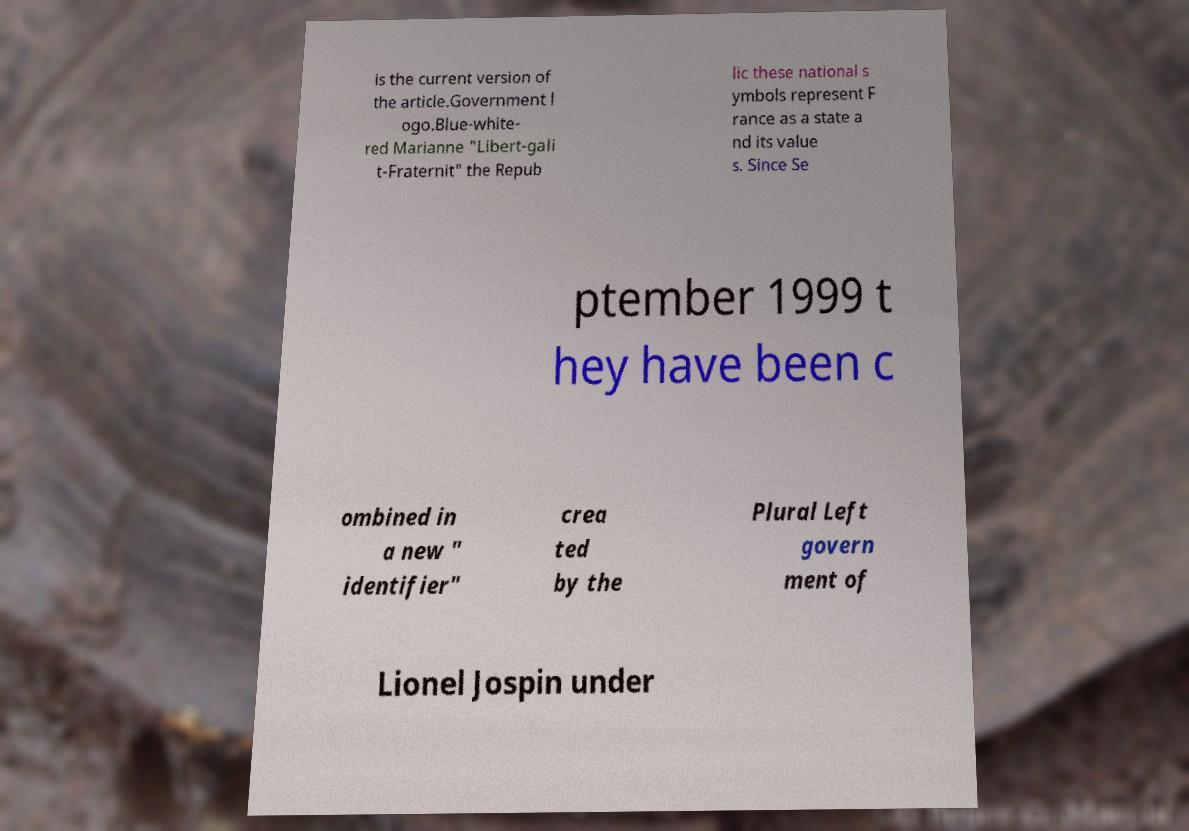There's text embedded in this image that I need extracted. Can you transcribe it verbatim? is the current version of the article.Government l ogo.Blue-white- red Marianne "Libert-gali t-Fraternit" the Repub lic these national s ymbols represent F rance as a state a nd its value s. Since Se ptember 1999 t hey have been c ombined in a new " identifier" crea ted by the Plural Left govern ment of Lionel Jospin under 